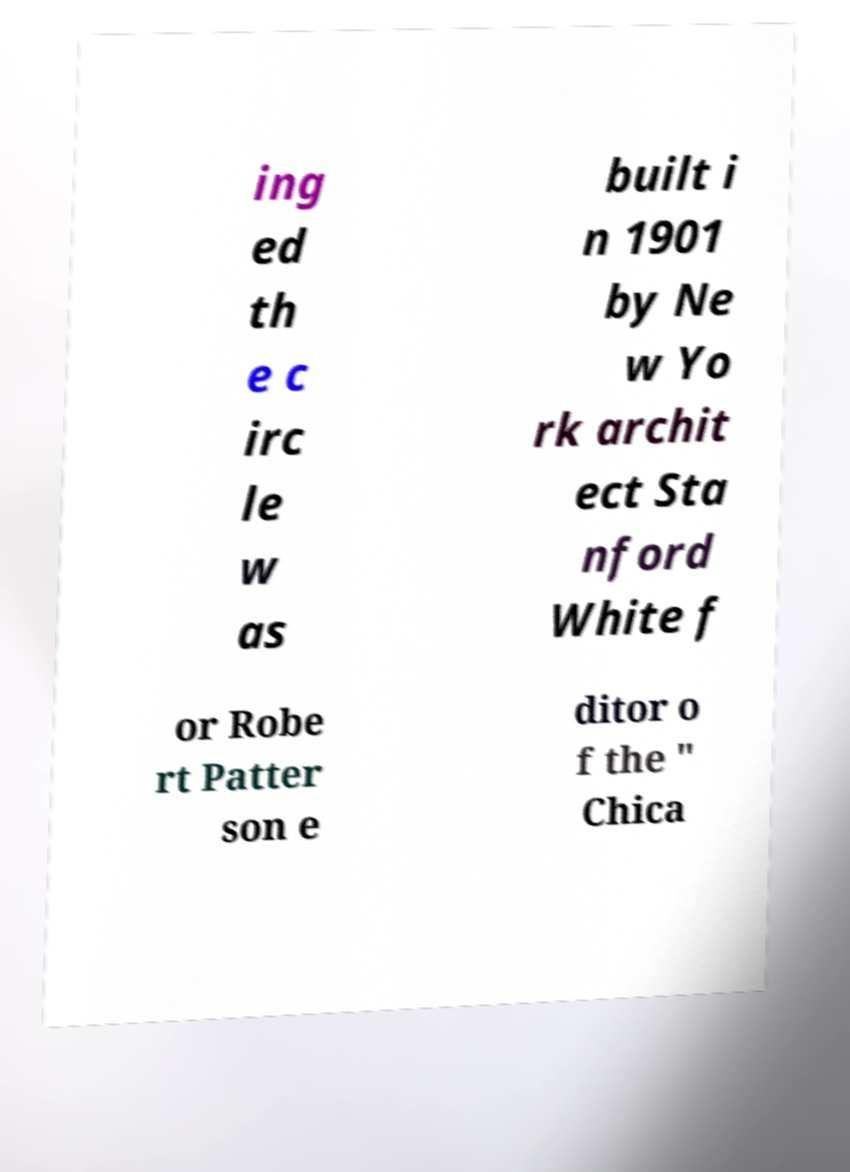Please identify and transcribe the text found in this image. ing ed th e c irc le w as built i n 1901 by Ne w Yo rk archit ect Sta nford White f or Robe rt Patter son e ditor o f the " Chica 